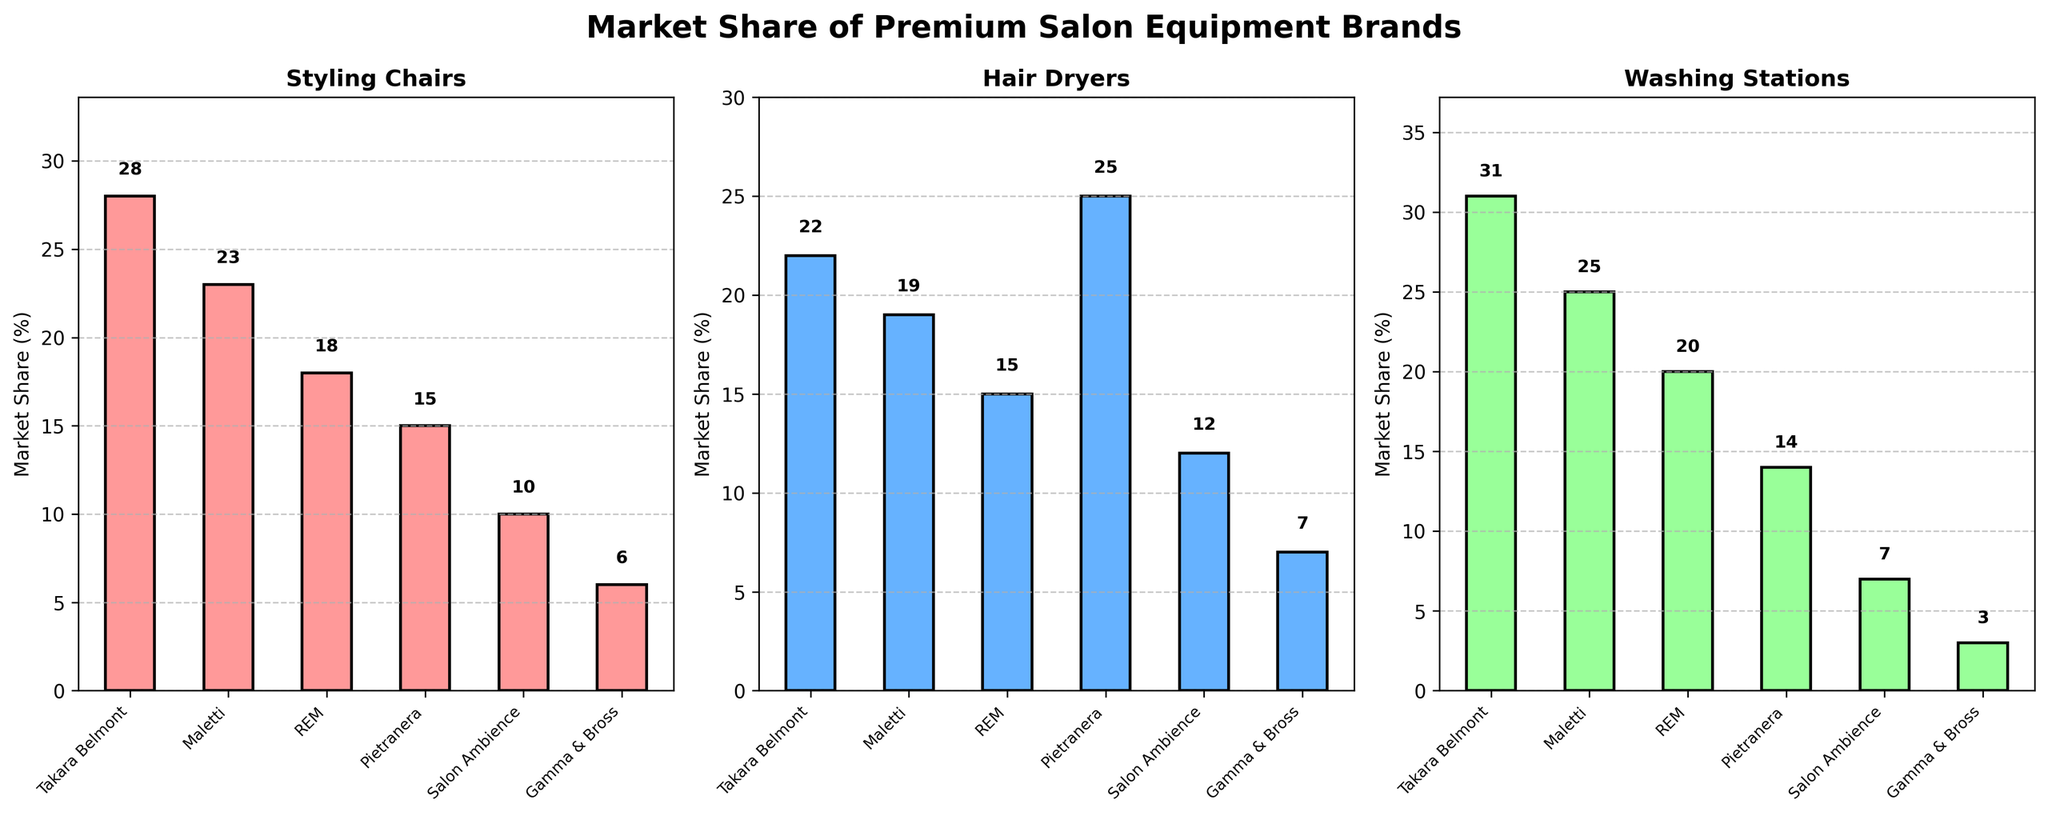Who has the highest market share in Styling Chairs? The bar for Styling Chairs is highest for Takara Belmont at 28% as depicted by the corresponding bar chart.
Answer: Takara Belmont What is the total market share of REM for all categories? Summing up REM's shares: Styling Chairs (18%) + Hair Dryers (15%) + Washing Stations (20%) = 53%.
Answer: 53% Which categories have their market leader as Pietranera? Pietranera leads the market in Hair Dryers with 25%, which is higher than any other brand in that category.
Answer: Hair Dryers How much more market share does Takara Belmont have in Washing Stations compared to Salon Ambience? Comparing their shares in Washing Stations: Takara Belmont (31%) - Salon Ambience (7%) = 24%.
Answer: 24% Which brand has the lowest market share in all the categories combined? By inspecting each category, we find Gamma & Bross has the smallest values: Styling Chairs (6%), Hair Dryers (7%), Washing Stations (3%) leading to the lowest combined total.
Answer: Gamma & Bross List all brands with a market share above 20% in any category. Takara Belmont, Maletti, and Pietranera all have market shares above 20% in one or more categories.
Answer: Takara Belmont, Maletti, Pietranera Is there a brand that has a consistent market share across all categories? Scanning across all values, no brand shows the same market share in all three categories.
Answer: No What's the difference in market share between the highest and second-highest brands for Hair Dryers? Pietranera (25%) and Takara Belmont (22%) are the top two; their difference is 3%.
Answer: 3% Identify the brand with the second-highest market share in Washing Stations. Maletti has the second-highest market share in Washing Stations with 25%.
Answer: Maletti What is the mean market share of Maletti across all the categories? The shares are 23%, 19%, and 25%. Average: (23+19+25)/3 = 22.3%.
Answer: 22.3% 